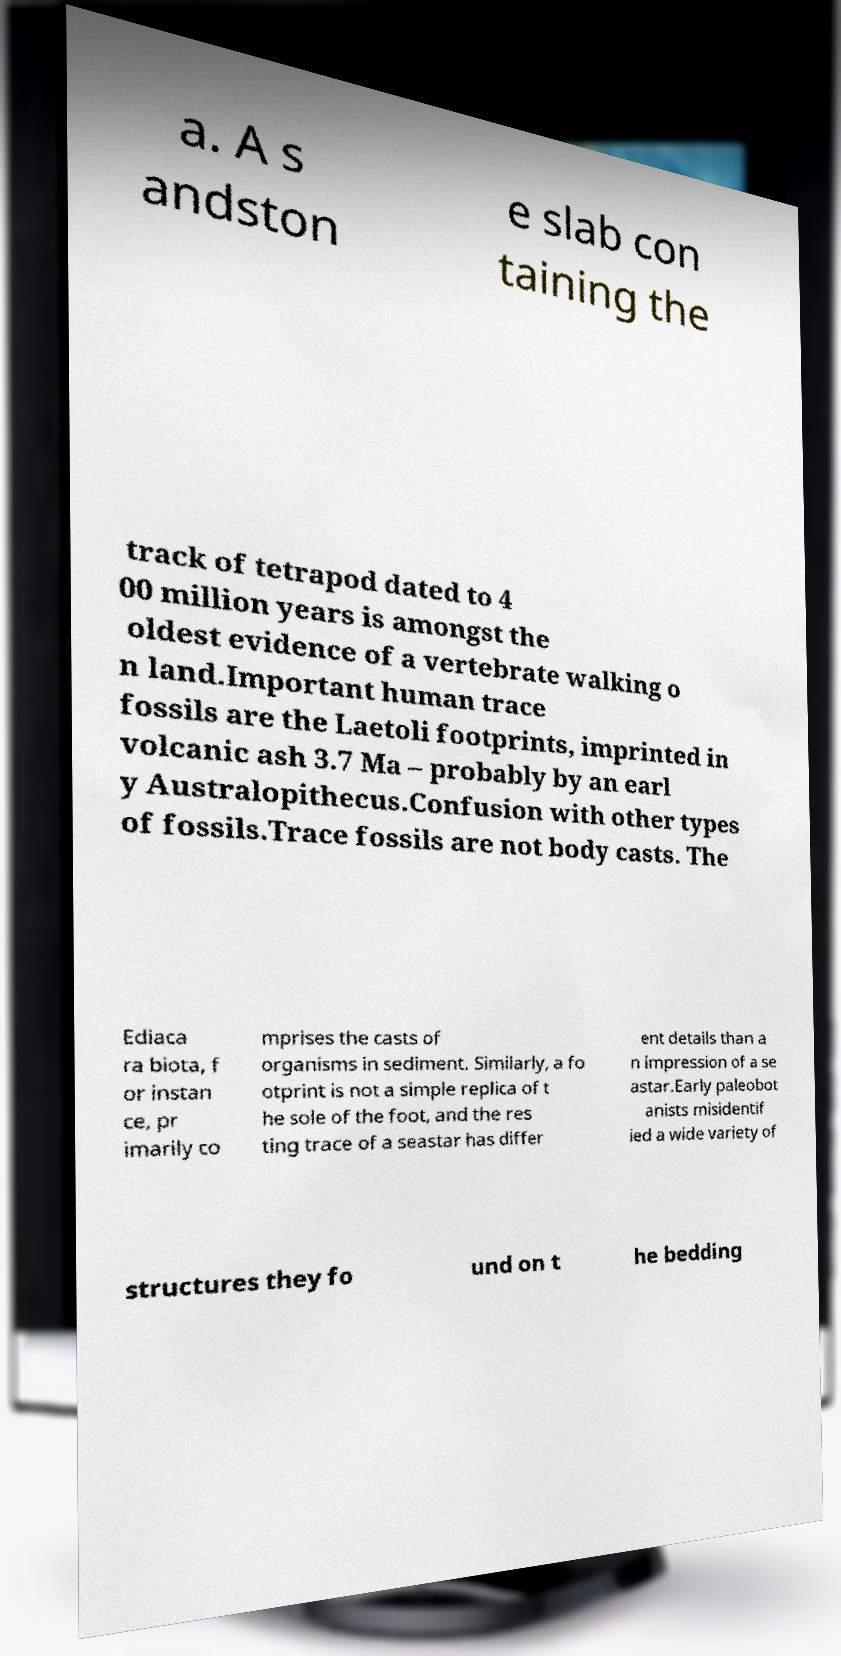I need the written content from this picture converted into text. Can you do that? a. A s andston e slab con taining the track of tetrapod dated to 4 00 million years is amongst the oldest evidence of a vertebrate walking o n land.Important human trace fossils are the Laetoli footprints, imprinted in volcanic ash 3.7 Ma – probably by an earl y Australopithecus.Confusion with other types of fossils.Trace fossils are not body casts. The Ediaca ra biota, f or instan ce, pr imarily co mprises the casts of organisms in sediment. Similarly, a fo otprint is not a simple replica of t he sole of the foot, and the res ting trace of a seastar has differ ent details than a n impression of a se astar.Early paleobot anists misidentif ied a wide variety of structures they fo und on t he bedding 